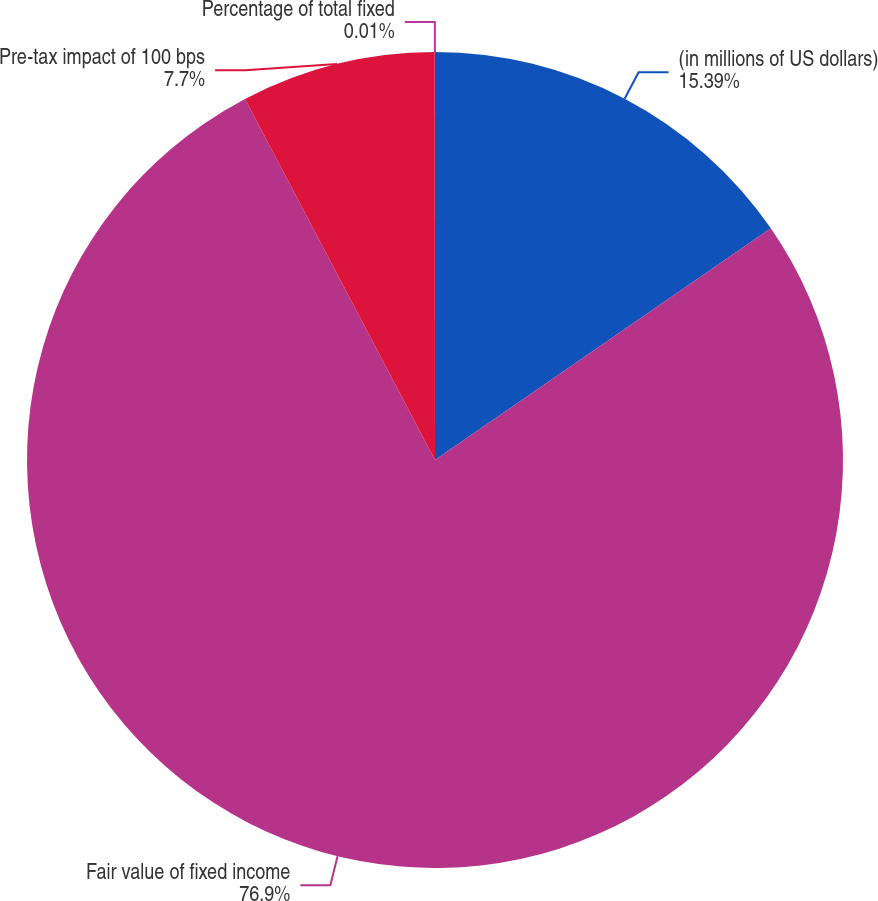Convert chart to OTSL. <chart><loc_0><loc_0><loc_500><loc_500><pie_chart><fcel>(in millions of US dollars)<fcel>Fair value of fixed income<fcel>Pre-tax impact of 100 bps<fcel>Percentage of total fixed<nl><fcel>15.39%<fcel>76.91%<fcel>7.7%<fcel>0.01%<nl></chart> 